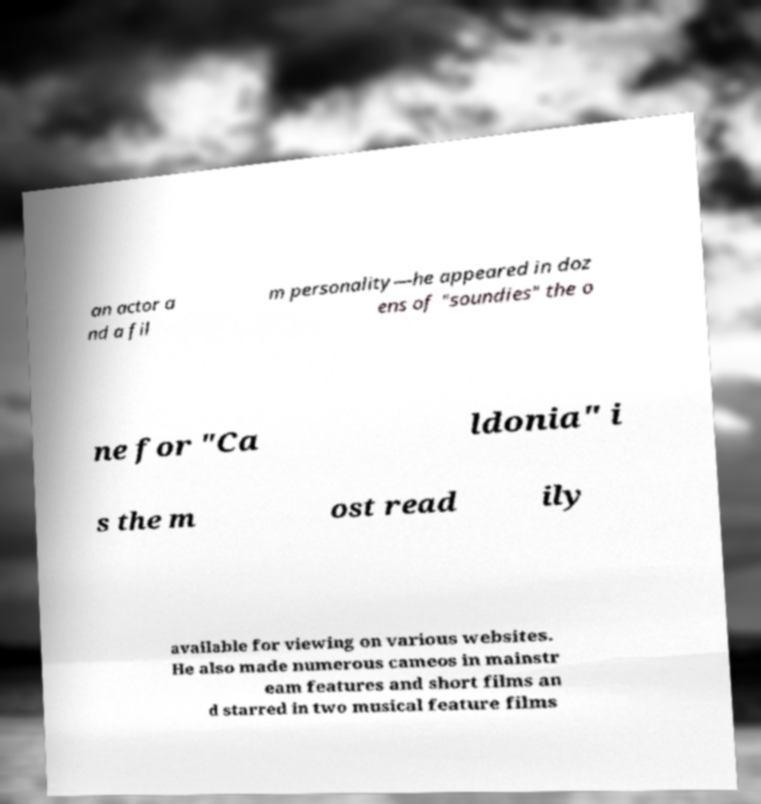Could you extract and type out the text from this image? an actor a nd a fil m personality—he appeared in doz ens of "soundies" the o ne for "Ca ldonia" i s the m ost read ily available for viewing on various websites. He also made numerous cameos in mainstr eam features and short films an d starred in two musical feature films 